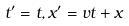<formula> <loc_0><loc_0><loc_500><loc_500>t ^ { \prime } = t , x ^ { \prime } = v t + x</formula> 